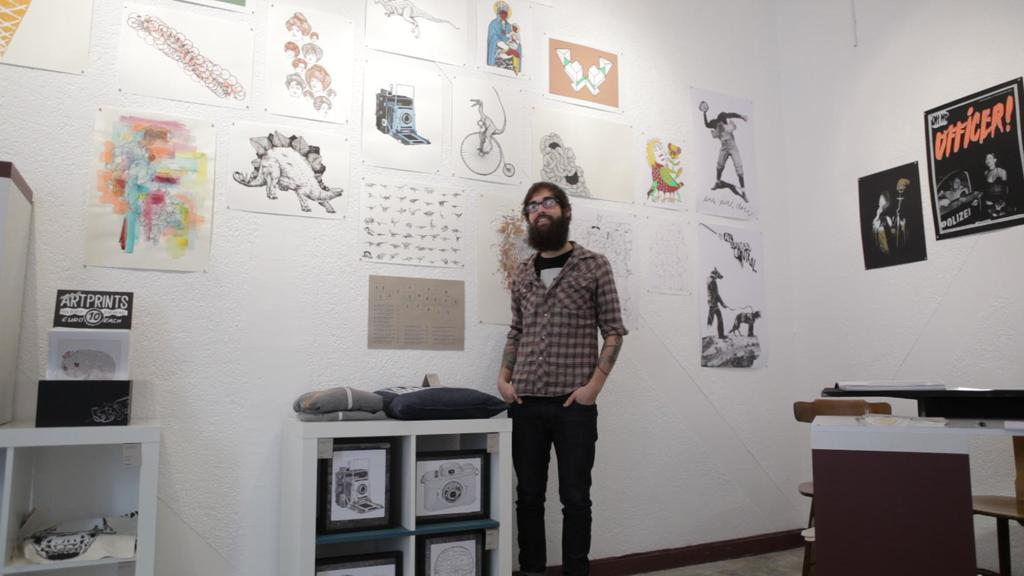Who is present in the image? There is a man in the image. What is the man doing in the image? The man is standing in front of a wall and smiling. What can be seen behind the man? There are arts and posters in the background of the image. What is present on the racks in the image? There are items on the racks in the image. What type of engine can be seen in the image? There is no engine present in the image. Is there a girl in the image? The image only features a man, and there is no mention of a girl. 